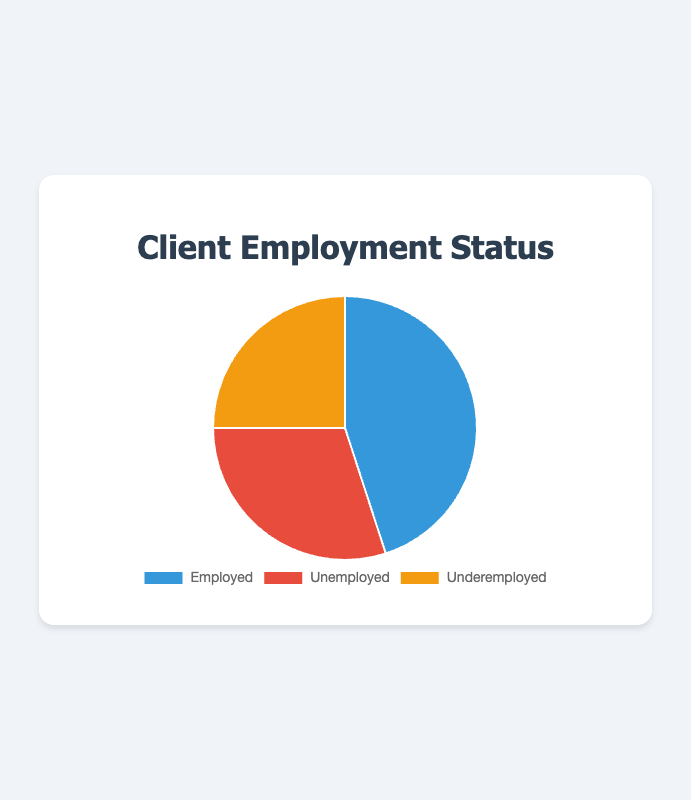what percentage of clients are employed? The chart shows 45 clients are employed. To find the percentage, divide the number of employed by the total number of clients: (45/100) * 100%=45%.
Answer: 45% Which employment status has the highest number of clients? The number of clients for each status is listed in the chart. Comparing them: Employed (45), Unemployed (30), Underemployed (25), we see Employed has the highest number.
Answer: Employed What is the combined percentage of unemployed and underemployed clients? Add the number of Unemployed (30) and Underemployed (25): 30 + 25 = 55. Then, divide by total clients (100) and multiply by 100 to get the percentage: (55/100) * 100%=55%.
Answer: 55% How many more clients are employed compared to underemployed? The chart indicates 45 clients are employed and 25 are underemployed. Subtract the number of underemployed from employed: 45 - 25 = 20.
Answer: 20 What portion of the pie chart is represented by underemployed clients? There are 25 underemployed clients out of 100 total clients. To find the portion, divide the number of underemployed by the total: 25/100=0.25. Multiply by 100 to convert to percentage: 0.25*100=25%.
Answer: 25% Are there more employed or unemployed clients? By comparing the values: Employed (45) and Unemployed (30), it's clear that there are more employed clients.
Answer: Employed What is the ratio of employed to unemployed clients? There are 45 employed and 30 unemployed clients. To find the ratio, divide the number of employed by unemployed: 45/30=3/2 or 1.5.
Answer: 1.5 What percentage of clients are not employed (either unemployed or underemployed)? Unemployed clients (30) + Underemployed clients (25) gives a total of 55 clients. To find the percentage: (55/100) * 100%=55%.
Answer: 55% What's the difference in the proportion of unemployed and underemployed clients as a percentage? Unemployed: 30 out of 100 (30%). Underemployed: 25 out of 100 (25%). Difference = 30% - 25% = 5%.
Answer: 5% 